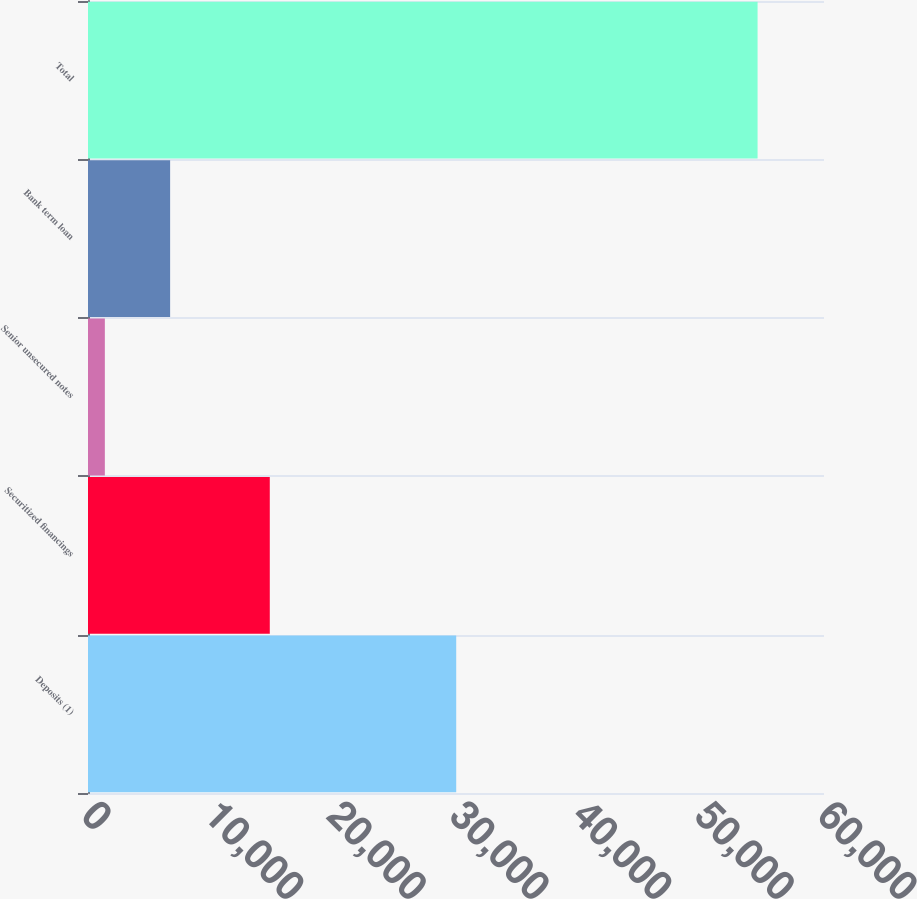Convert chart to OTSL. <chart><loc_0><loc_0><loc_500><loc_500><bar_chart><fcel>Deposits (1)<fcel>Securitized financings<fcel>Senior unsecured notes<fcel>Bank term loan<fcel>Total<nl><fcel>30017<fcel>14820<fcel>1374<fcel>6695.1<fcel>54585<nl></chart> 